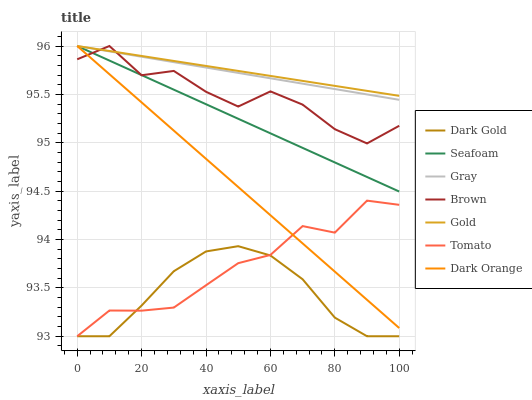Does Dark Gold have the minimum area under the curve?
Answer yes or no. Yes. Does Gold have the maximum area under the curve?
Answer yes or no. Yes. Does Gray have the minimum area under the curve?
Answer yes or no. No. Does Gray have the maximum area under the curve?
Answer yes or no. No. Is Gold the smoothest?
Answer yes or no. Yes. Is Brown the roughest?
Answer yes or no. Yes. Is Gray the smoothest?
Answer yes or no. No. Is Gray the roughest?
Answer yes or no. No. Does Gray have the lowest value?
Answer yes or no. No. Does Dark Orange have the highest value?
Answer yes or no. Yes. Does Dark Gold have the highest value?
Answer yes or no. No. Is Dark Gold less than Gray?
Answer yes or no. Yes. Is Brown greater than Tomato?
Answer yes or no. Yes. Does Gold intersect Dark Orange?
Answer yes or no. Yes. Is Gold less than Dark Orange?
Answer yes or no. No. Is Gold greater than Dark Orange?
Answer yes or no. No. Does Dark Gold intersect Gray?
Answer yes or no. No. 